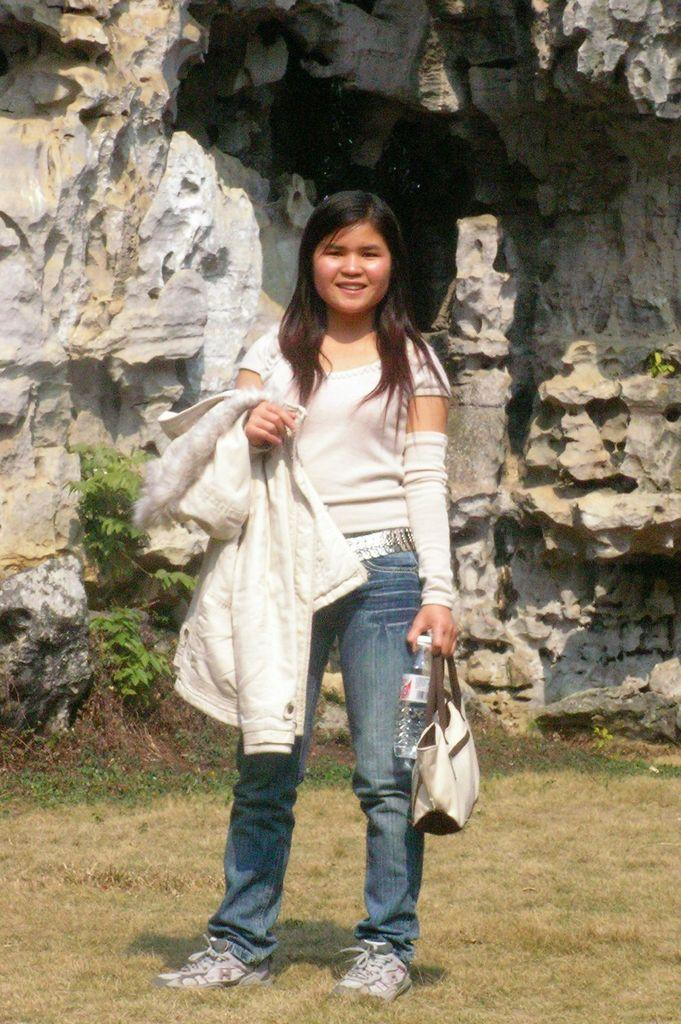What is the main subject of the image? The main subject of the image is a woman. What is the woman holding in the image? The woman is holding a handbag. What type of van can be seen in the background of the image? There is no van present in the image; it only features a woman holding a handbag. What kind of apparatus is the woman using to communicate in the image? There is no apparatus visible in the image; the woman is simply holding a handbag. 